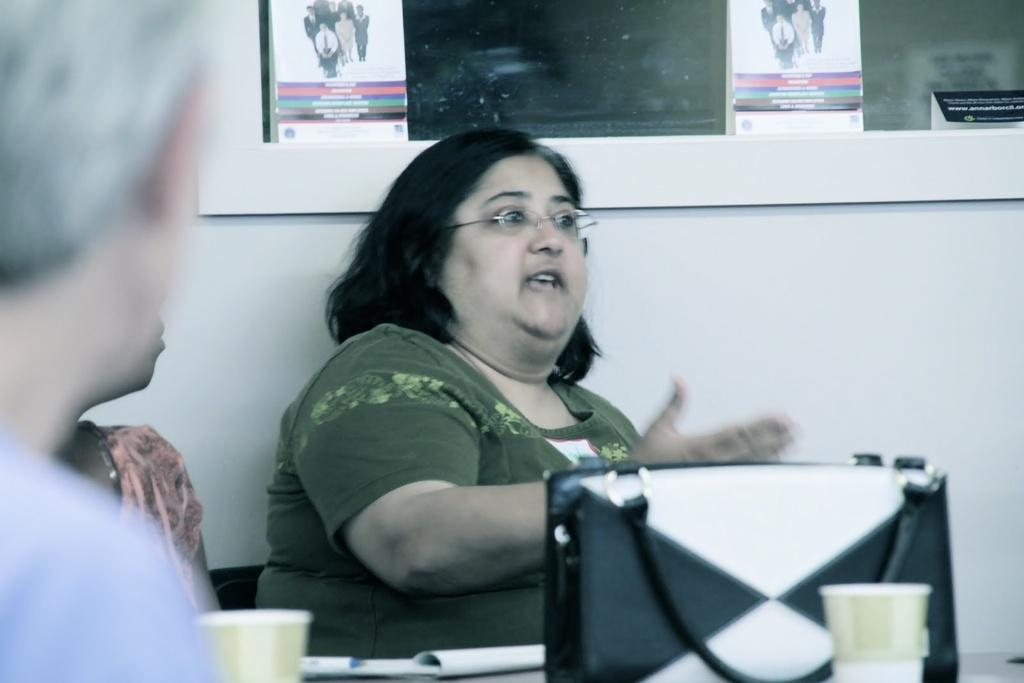What is the woman in the image doing? The woman is sitting and talking in the image. Can you describe something on the wall in the image? Yes, there is a board present on the wall in the image. Where are the dolls placed on the tray in the image? There are no dolls or tray present in the image. What type of playground equipment can be seen in the image? There is no playground equipment visible in the image. 